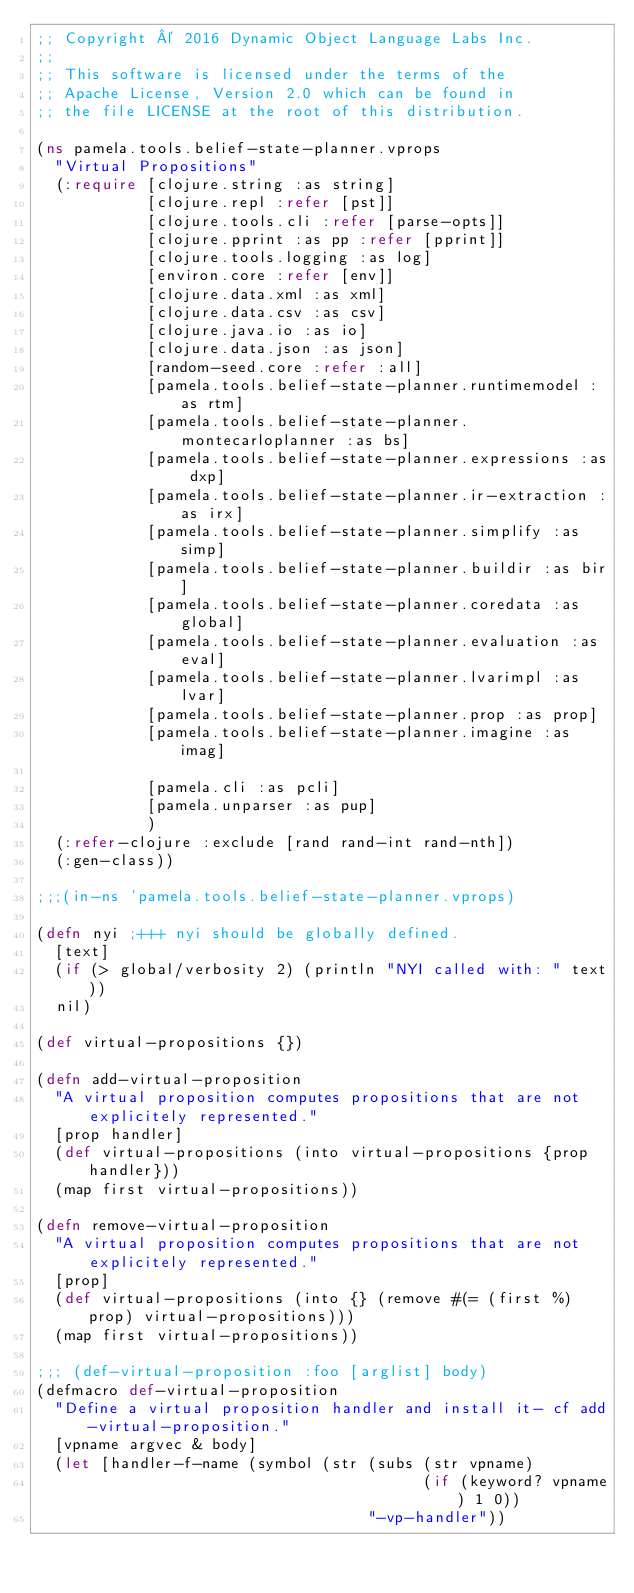Convert code to text. <code><loc_0><loc_0><loc_500><loc_500><_Clojure_>;; Copyright © 2016 Dynamic Object Language Labs Inc.
;;
;; This software is licensed under the terms of the
;; Apache License, Version 2.0 which can be found in
;; the file LICENSE at the root of this distribution.

(ns pamela.tools.belief-state-planner.vprops
  "Virtual Propositions"
  (:require [clojure.string :as string]
            [clojure.repl :refer [pst]]
            [clojure.tools.cli :refer [parse-opts]]
            [clojure.pprint :as pp :refer [pprint]]
            [clojure.tools.logging :as log]
            [environ.core :refer [env]]
            [clojure.data.xml :as xml]
            [clojure.data.csv :as csv]
            [clojure.java.io :as io]
            [clojure.data.json :as json]
            [random-seed.core :refer :all]
            [pamela.tools.belief-state-planner.runtimemodel :as rtm]
            [pamela.tools.belief-state-planner.montecarloplanner :as bs]
            [pamela.tools.belief-state-planner.expressions :as dxp]
            [pamela.tools.belief-state-planner.ir-extraction :as irx]
            [pamela.tools.belief-state-planner.simplify :as simp]
            [pamela.tools.belief-state-planner.buildir :as bir]
            [pamela.tools.belief-state-planner.coredata :as global]
            [pamela.tools.belief-state-planner.evaluation :as eval]
            [pamela.tools.belief-state-planner.lvarimpl :as lvar]
            [pamela.tools.belief-state-planner.prop :as prop]
            [pamela.tools.belief-state-planner.imagine :as imag]

            [pamela.cli :as pcli]
            [pamela.unparser :as pup]
            )
  (:refer-clojure :exclude [rand rand-int rand-nth])
  (:gen-class))

;;;(in-ns 'pamela.tools.belief-state-planner.vprops)

(defn nyi ;+++ nyi should be globally defined.
  [text]
  (if (> global/verbosity 2) (println "NYI called with: " text))
  nil)

(def virtual-propositions {})

(defn add-virtual-proposition
  "A virtual proposition computes propositions that are not explicitely represented."
  [prop handler]
  (def virtual-propositions (into virtual-propositions {prop handler}))
  (map first virtual-propositions))

(defn remove-virtual-proposition
  "A virtual proposition computes propositions that are not explicitely represented."
  [prop]
  (def virtual-propositions (into {} (remove #(= (first %) prop) virtual-propositions)))
  (map first virtual-propositions))

;;; (def-virtual-proposition :foo [arglist] body)
(defmacro def-virtual-proposition
  "Define a virtual proposition handler and install it- cf add-virtual-proposition."
  [vpname argvec & body]
  (let [handler-f-name (symbol (str (subs (str vpname)
                                          (if (keyword? vpname) 1 0))
                                    "-vp-handler"))</code> 